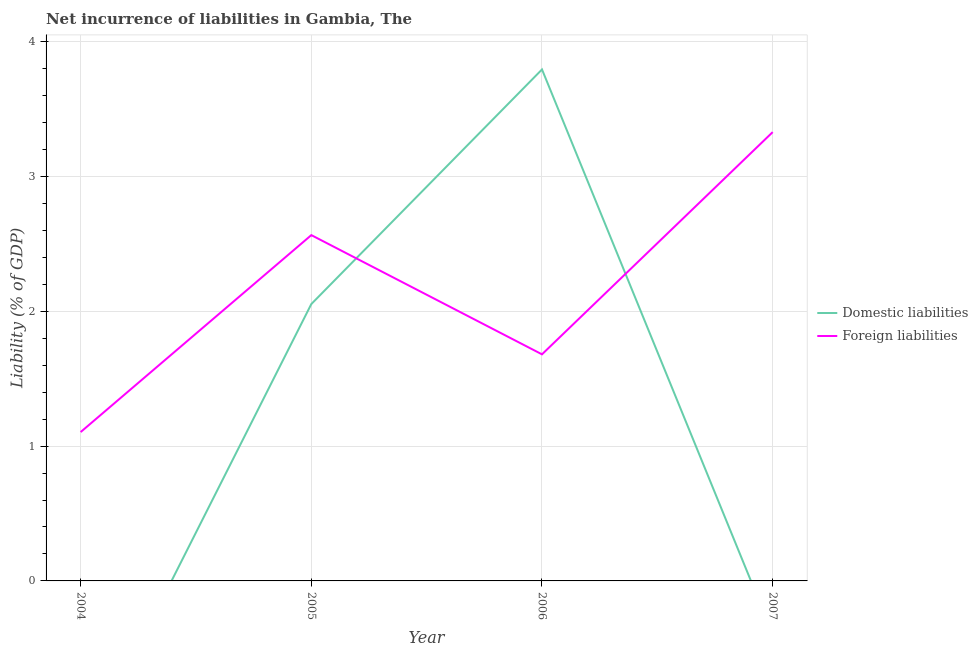How many different coloured lines are there?
Your answer should be compact. 2. What is the incurrence of domestic liabilities in 2006?
Make the answer very short. 3.79. Across all years, what is the maximum incurrence of domestic liabilities?
Ensure brevity in your answer.  3.79. Across all years, what is the minimum incurrence of domestic liabilities?
Your response must be concise. 0. What is the total incurrence of foreign liabilities in the graph?
Keep it short and to the point. 8.68. What is the difference between the incurrence of foreign liabilities in 2004 and that in 2006?
Your answer should be very brief. -0.58. What is the difference between the incurrence of foreign liabilities in 2005 and the incurrence of domestic liabilities in 2004?
Your answer should be compact. 2.57. What is the average incurrence of domestic liabilities per year?
Your answer should be very brief. 1.46. In the year 2006, what is the difference between the incurrence of domestic liabilities and incurrence of foreign liabilities?
Your answer should be very brief. 2.11. What is the ratio of the incurrence of foreign liabilities in 2004 to that in 2005?
Provide a succinct answer. 0.43. Is the incurrence of foreign liabilities in 2006 less than that in 2007?
Provide a short and direct response. Yes. What is the difference between the highest and the second highest incurrence of foreign liabilities?
Make the answer very short. 0.76. What is the difference between the highest and the lowest incurrence of foreign liabilities?
Give a very brief answer. 2.22. Does the incurrence of foreign liabilities monotonically increase over the years?
Offer a terse response. No. How many lines are there?
Provide a succinct answer. 2. How many years are there in the graph?
Offer a terse response. 4. What is the difference between two consecutive major ticks on the Y-axis?
Your answer should be compact. 1. Are the values on the major ticks of Y-axis written in scientific E-notation?
Offer a very short reply. No. Does the graph contain any zero values?
Provide a succinct answer. Yes. Does the graph contain grids?
Ensure brevity in your answer.  Yes. How are the legend labels stacked?
Your response must be concise. Vertical. What is the title of the graph?
Offer a very short reply. Net incurrence of liabilities in Gambia, The. Does "Urban agglomerations" appear as one of the legend labels in the graph?
Your answer should be very brief. No. What is the label or title of the X-axis?
Provide a short and direct response. Year. What is the label or title of the Y-axis?
Make the answer very short. Liability (% of GDP). What is the Liability (% of GDP) in Domestic liabilities in 2004?
Keep it short and to the point. 0. What is the Liability (% of GDP) of Foreign liabilities in 2004?
Give a very brief answer. 1.1. What is the Liability (% of GDP) of Domestic liabilities in 2005?
Give a very brief answer. 2.05. What is the Liability (% of GDP) of Foreign liabilities in 2005?
Your answer should be compact. 2.57. What is the Liability (% of GDP) of Domestic liabilities in 2006?
Give a very brief answer. 3.79. What is the Liability (% of GDP) in Foreign liabilities in 2006?
Keep it short and to the point. 1.68. What is the Liability (% of GDP) in Domestic liabilities in 2007?
Ensure brevity in your answer.  0. What is the Liability (% of GDP) in Foreign liabilities in 2007?
Your response must be concise. 3.33. Across all years, what is the maximum Liability (% of GDP) of Domestic liabilities?
Provide a short and direct response. 3.79. Across all years, what is the maximum Liability (% of GDP) of Foreign liabilities?
Provide a short and direct response. 3.33. Across all years, what is the minimum Liability (% of GDP) of Foreign liabilities?
Your response must be concise. 1.1. What is the total Liability (% of GDP) in Domestic liabilities in the graph?
Your response must be concise. 5.85. What is the total Liability (% of GDP) in Foreign liabilities in the graph?
Ensure brevity in your answer.  8.68. What is the difference between the Liability (% of GDP) of Foreign liabilities in 2004 and that in 2005?
Provide a succinct answer. -1.46. What is the difference between the Liability (% of GDP) of Foreign liabilities in 2004 and that in 2006?
Your response must be concise. -0.58. What is the difference between the Liability (% of GDP) of Foreign liabilities in 2004 and that in 2007?
Your answer should be compact. -2.23. What is the difference between the Liability (% of GDP) in Domestic liabilities in 2005 and that in 2006?
Make the answer very short. -1.74. What is the difference between the Liability (% of GDP) of Foreign liabilities in 2005 and that in 2006?
Provide a succinct answer. 0.88. What is the difference between the Liability (% of GDP) in Foreign liabilities in 2005 and that in 2007?
Offer a very short reply. -0.76. What is the difference between the Liability (% of GDP) of Foreign liabilities in 2006 and that in 2007?
Provide a short and direct response. -1.65. What is the difference between the Liability (% of GDP) of Domestic liabilities in 2005 and the Liability (% of GDP) of Foreign liabilities in 2006?
Provide a succinct answer. 0.37. What is the difference between the Liability (% of GDP) of Domestic liabilities in 2005 and the Liability (% of GDP) of Foreign liabilities in 2007?
Offer a terse response. -1.28. What is the difference between the Liability (% of GDP) in Domestic liabilities in 2006 and the Liability (% of GDP) in Foreign liabilities in 2007?
Give a very brief answer. 0.46. What is the average Liability (% of GDP) in Domestic liabilities per year?
Make the answer very short. 1.46. What is the average Liability (% of GDP) of Foreign liabilities per year?
Your answer should be compact. 2.17. In the year 2005, what is the difference between the Liability (% of GDP) in Domestic liabilities and Liability (% of GDP) in Foreign liabilities?
Your response must be concise. -0.51. In the year 2006, what is the difference between the Liability (% of GDP) in Domestic liabilities and Liability (% of GDP) in Foreign liabilities?
Make the answer very short. 2.11. What is the ratio of the Liability (% of GDP) in Foreign liabilities in 2004 to that in 2005?
Give a very brief answer. 0.43. What is the ratio of the Liability (% of GDP) in Foreign liabilities in 2004 to that in 2006?
Ensure brevity in your answer.  0.66. What is the ratio of the Liability (% of GDP) of Foreign liabilities in 2004 to that in 2007?
Your response must be concise. 0.33. What is the ratio of the Liability (% of GDP) of Domestic liabilities in 2005 to that in 2006?
Give a very brief answer. 0.54. What is the ratio of the Liability (% of GDP) of Foreign liabilities in 2005 to that in 2006?
Offer a very short reply. 1.53. What is the ratio of the Liability (% of GDP) of Foreign liabilities in 2005 to that in 2007?
Give a very brief answer. 0.77. What is the ratio of the Liability (% of GDP) in Foreign liabilities in 2006 to that in 2007?
Give a very brief answer. 0.5. What is the difference between the highest and the second highest Liability (% of GDP) in Foreign liabilities?
Your response must be concise. 0.76. What is the difference between the highest and the lowest Liability (% of GDP) in Domestic liabilities?
Give a very brief answer. 3.79. What is the difference between the highest and the lowest Liability (% of GDP) in Foreign liabilities?
Keep it short and to the point. 2.23. 